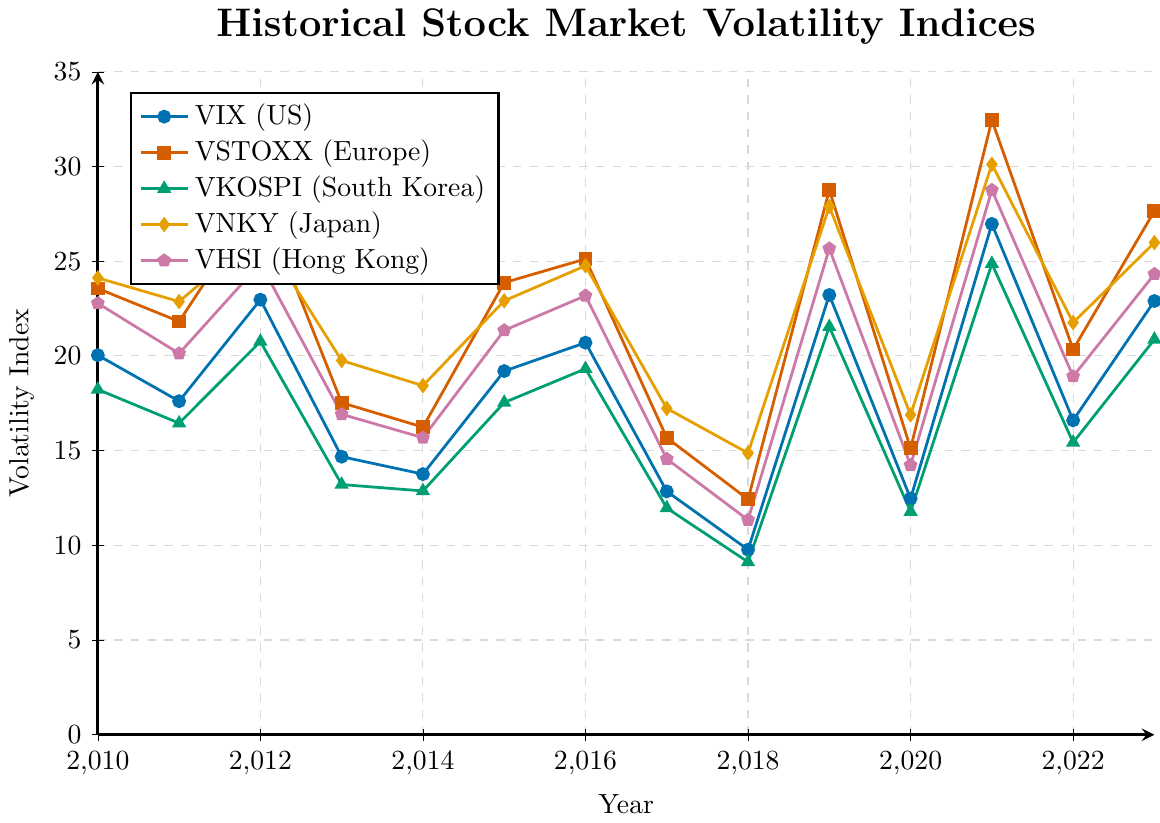Which year had the highest VIX (US) value? Observing the plot for the VIX (US) line, the highest point on the line occurs at the year 2021.
Answer: 2021 Which indices have values above 25 in the year 2019? Detecting the points for each line at 2019 on the plot, both VIX (US), VSTOXX (Europe), VNKY (Japan), and VHSI (Hong Kong) are above the value of 25.
Answer: VIX (US), VSTOXX (Europe), VNKY (Japan), VHSI (Hong Kong) What is the average volatility index for VKOSPI (South Korea) from 2010 to 2013? Taking the four values for VKOSPI (South Korea) from 2010 to 2013: 18.23, 16.45, 20.76, and 13.21, and averaging them: (18.23 + 16.45 + 20.76 + 13.21) / 4 = 17.16
Answer: 17.16 Compare the VSTOXX (Europe) value in 2016 and 2021; which year is higher and by how much? Observing the coordinates for VSTOXX (Europe) in 2016 (25.12) and 2021 (32.45), 2021 is higher. The difference is 32.45 - 25.12 = 7.33
Answer: 2021, 7.33 What is the trend of VNKY (Japan) from 2017 to 2020? Observing the VNKY (Japan) points from 2017 (17.23), 2018 (14.87), 2019 (27.89), and 2020 (16.89), the trend shows a decrease from 2017 to 2018, an increase in 2019, and a decrease again in 2020.
Answer: Alternate increase and decrease Which index shows the smallest value across all years? Observing all the points on the plot, VKOSPI (South Korea) in 2018 has the smallest value with 9.12.
Answer: VKOSPI (South Korea) in 2018 How many times did VIX (US) surpass 20 in the given years? Counting the years where VIX (US) is above 20: 2010 (20.04), 2012 (22.97), 2015 (19.20 does not count), 2016 (20.70), 2019 (23.22), 2021 (26.97), and 2023 (22.90), it happened five times.
Answer: 5 times Calculate the difference between VSTOXX (Europe) and VHSI (Hong Kong) in 2023. Observing VSTOXX (Europe) in 2023 (27.65) and VHSI (Hong Kong) in 2023 (24.32), their difference is 27.65 - 24.32 = 3.33
Answer: 3.33 What's the visual pattern of VKOSPI (South Korea) across the entire period? Observing the line for VKOSPI (South Korea), there is a general pattern of fluctuation with both high and low points throughout the years, showing volatility typical of an index.
Answer: Fluctuating 